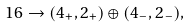Convert formula to latex. <formula><loc_0><loc_0><loc_500><loc_500>1 6 \to ( 4 _ { + } , 2 _ { + } ) \oplus ( 4 _ { - } , 2 _ { - } ) ,</formula> 